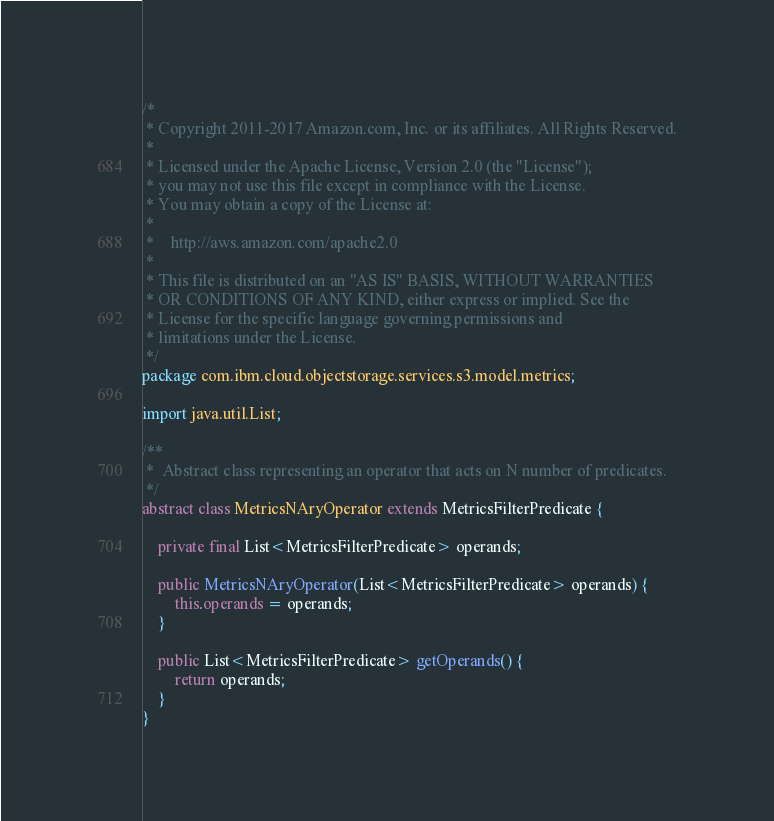Convert code to text. <code><loc_0><loc_0><loc_500><loc_500><_Java_>/*
 * Copyright 2011-2017 Amazon.com, Inc. or its affiliates. All Rights Reserved.
 *
 * Licensed under the Apache License, Version 2.0 (the "License");
 * you may not use this file except in compliance with the License.
 * You may obtain a copy of the License at:
 *
 *    http://aws.amazon.com/apache2.0
 *
 * This file is distributed on an "AS IS" BASIS, WITHOUT WARRANTIES
 * OR CONDITIONS OF ANY KIND, either express or implied. See the
 * License for the specific language governing permissions and
 * limitations under the License.
 */
package com.ibm.cloud.objectstorage.services.s3.model.metrics;

import java.util.List;

/**
 *  Abstract class representing an operator that acts on N number of predicates.
 */
abstract class MetricsNAryOperator extends MetricsFilterPredicate {

    private final List<MetricsFilterPredicate> operands;

    public MetricsNAryOperator(List<MetricsFilterPredicate> operands) {
        this.operands = operands;
    }

    public List<MetricsFilterPredicate> getOperands() {
        return operands;
    }
}
</code> 